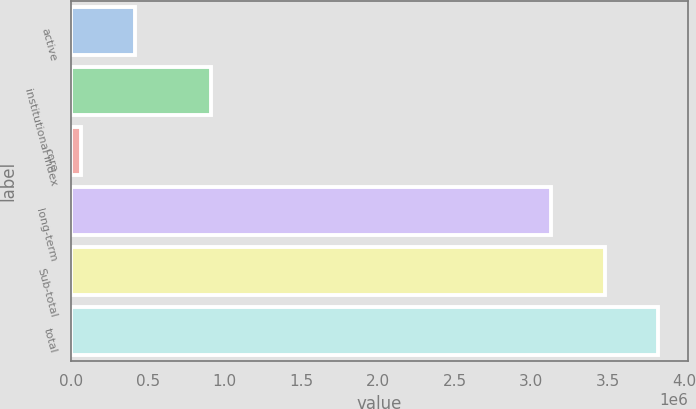<chart> <loc_0><loc_0><loc_500><loc_500><bar_chart><fcel>active<fcel>institutional index<fcel>core<fcel>long-term<fcel>Sub-total<fcel>total<nl><fcel>413340<fcel>911775<fcel>63603<fcel>3.13112e+06<fcel>3.48085e+06<fcel>3.83059e+06<nl></chart> 